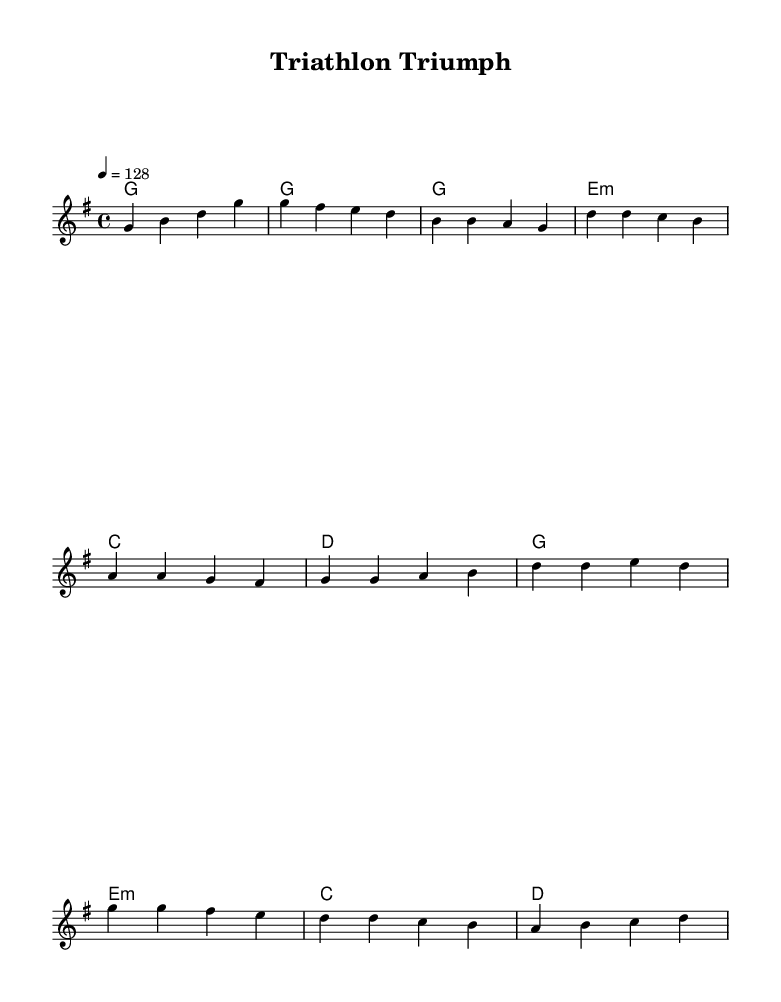What is the key signature of this music? The key signature can be identified by looking at the beginning of the score. It is indicated right after the clef and shows one sharp, which corresponds to G major.
Answer: G major What is the time signature of this music? The time signature is found directly after the key signature and is displayed as a fraction. In this case, it shows 4/4, indicating four beats per measure.
Answer: 4/4 What is the tempo marking for this piece? The tempo marking is shown with a note value and a number at the beginning of the score. Here, it is marked as "4 = 128," which indicates the speed of the song.
Answer: 128 What chords are used in the harmonies section? The chords can be identified in the chord mode section and include the letters that represent the chords played in this piece, which are G, E minor, C, and D.
Answer: G, E minor, C, D How many measures are there in the verse section? By counting the measures in the melody, the verse section consists of four measures. This can be found within the verse lyrics in the score.
Answer: 4 What is the main theme reflected in the lyrics? The lyrics reflect a motivational theme, suggesting perseverance and strength through phrases such as "push through the pain." The positive sentiment links it to the House music genre, which often focuses on uplifting topics.
Answer: Perseverance and strength 